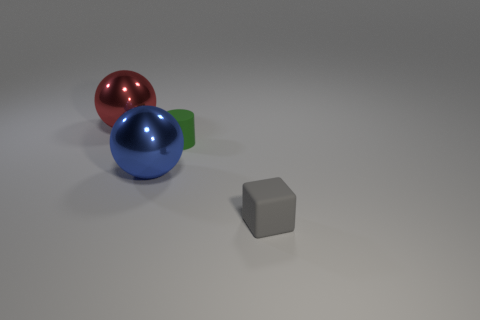Add 4 green things. How many objects exist? 8 Subtract all blocks. How many objects are left? 3 Add 1 small brown cubes. How many small brown cubes exist? 1 Subtract 0 cyan cylinders. How many objects are left? 4 Subtract all green blocks. Subtract all brown cylinders. How many blocks are left? 1 Subtract all tiny rubber cubes. Subtract all big blue metal spheres. How many objects are left? 2 Add 3 gray things. How many gray things are left? 4 